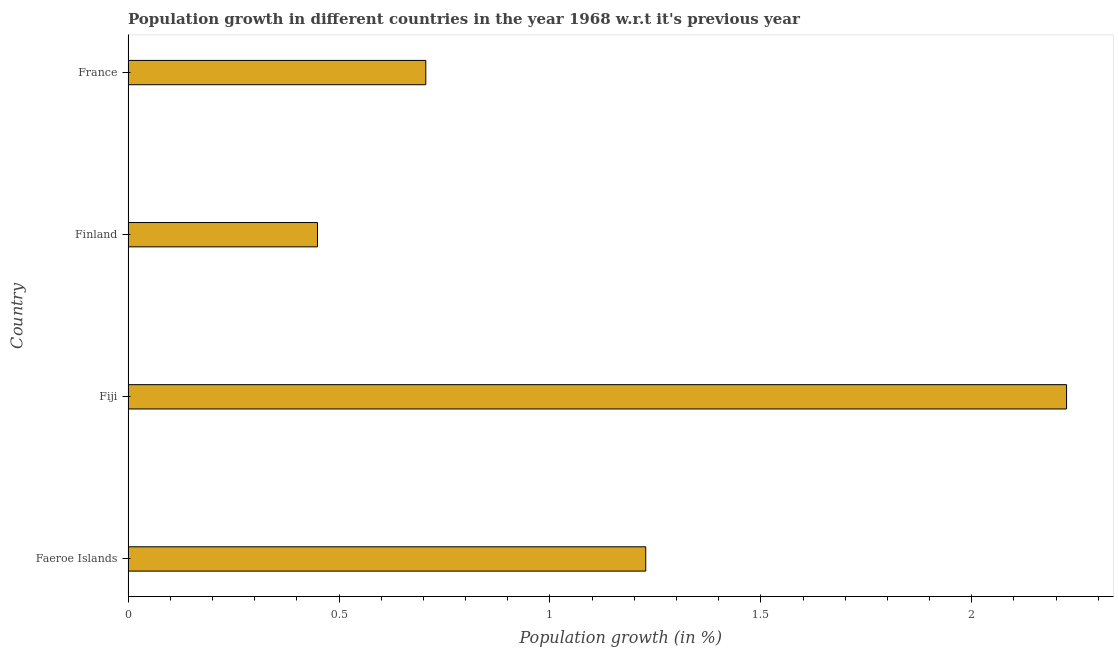Does the graph contain any zero values?
Ensure brevity in your answer.  No. What is the title of the graph?
Ensure brevity in your answer.  Population growth in different countries in the year 1968 w.r.t it's previous year. What is the label or title of the X-axis?
Keep it short and to the point. Population growth (in %). What is the population growth in Finland?
Your answer should be very brief. 0.45. Across all countries, what is the maximum population growth?
Make the answer very short. 2.22. Across all countries, what is the minimum population growth?
Keep it short and to the point. 0.45. In which country was the population growth maximum?
Keep it short and to the point. Fiji. What is the sum of the population growth?
Your answer should be compact. 4.61. What is the difference between the population growth in Faeroe Islands and Fiji?
Provide a succinct answer. -1. What is the average population growth per country?
Give a very brief answer. 1.15. What is the median population growth?
Make the answer very short. 0.97. In how many countries, is the population growth greater than 1.5 %?
Offer a very short reply. 1. What is the ratio of the population growth in Faeroe Islands to that in Finland?
Your answer should be very brief. 2.73. Is the sum of the population growth in Faeroe Islands and Fiji greater than the maximum population growth across all countries?
Offer a very short reply. Yes. What is the difference between the highest and the lowest population growth?
Give a very brief answer. 1.78. In how many countries, is the population growth greater than the average population growth taken over all countries?
Keep it short and to the point. 2. How many bars are there?
Your response must be concise. 4. Are all the bars in the graph horizontal?
Give a very brief answer. Yes. Are the values on the major ticks of X-axis written in scientific E-notation?
Give a very brief answer. No. What is the Population growth (in %) of Faeroe Islands?
Offer a very short reply. 1.23. What is the Population growth (in %) in Fiji?
Give a very brief answer. 2.22. What is the Population growth (in %) in Finland?
Provide a succinct answer. 0.45. What is the Population growth (in %) of France?
Ensure brevity in your answer.  0.71. What is the difference between the Population growth (in %) in Faeroe Islands and Fiji?
Ensure brevity in your answer.  -1. What is the difference between the Population growth (in %) in Faeroe Islands and Finland?
Offer a very short reply. 0.78. What is the difference between the Population growth (in %) in Faeroe Islands and France?
Give a very brief answer. 0.52. What is the difference between the Population growth (in %) in Fiji and Finland?
Provide a succinct answer. 1.78. What is the difference between the Population growth (in %) in Fiji and France?
Your answer should be very brief. 1.52. What is the difference between the Population growth (in %) in Finland and France?
Provide a short and direct response. -0.26. What is the ratio of the Population growth (in %) in Faeroe Islands to that in Fiji?
Keep it short and to the point. 0.55. What is the ratio of the Population growth (in %) in Faeroe Islands to that in Finland?
Your response must be concise. 2.73. What is the ratio of the Population growth (in %) in Faeroe Islands to that in France?
Make the answer very short. 1.74. What is the ratio of the Population growth (in %) in Fiji to that in Finland?
Offer a very short reply. 4.96. What is the ratio of the Population growth (in %) in Fiji to that in France?
Provide a short and direct response. 3.15. What is the ratio of the Population growth (in %) in Finland to that in France?
Give a very brief answer. 0.64. 